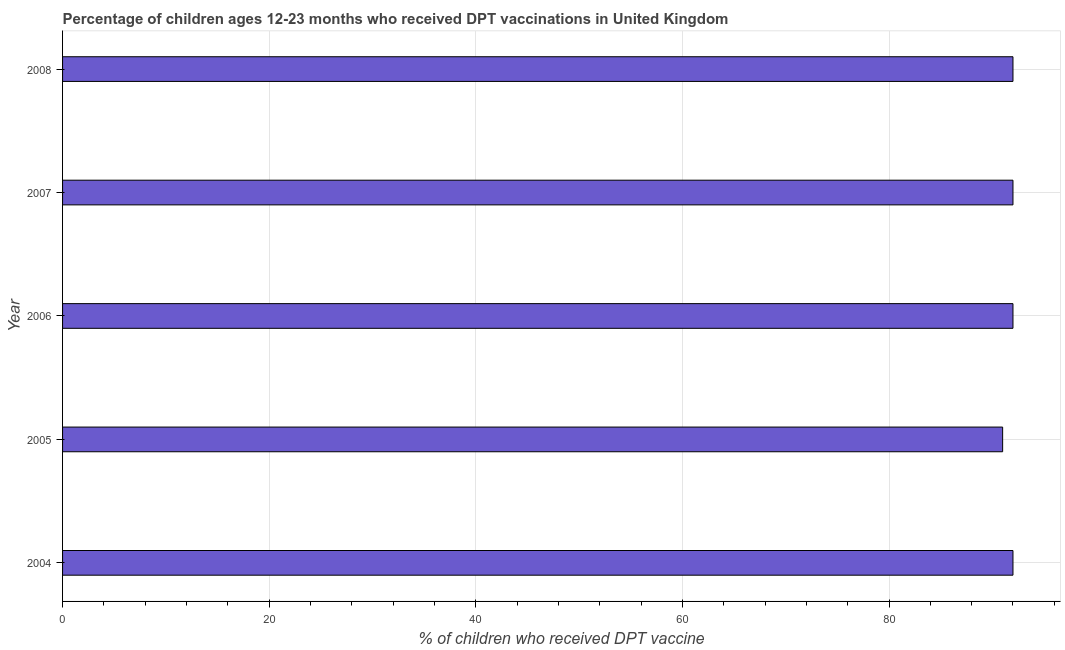Does the graph contain any zero values?
Offer a terse response. No. What is the title of the graph?
Ensure brevity in your answer.  Percentage of children ages 12-23 months who received DPT vaccinations in United Kingdom. What is the label or title of the X-axis?
Offer a terse response. % of children who received DPT vaccine. What is the percentage of children who received dpt vaccine in 2006?
Make the answer very short. 92. Across all years, what is the maximum percentage of children who received dpt vaccine?
Offer a terse response. 92. Across all years, what is the minimum percentage of children who received dpt vaccine?
Give a very brief answer. 91. What is the sum of the percentage of children who received dpt vaccine?
Keep it short and to the point. 459. What is the difference between the percentage of children who received dpt vaccine in 2007 and 2008?
Ensure brevity in your answer.  0. What is the average percentage of children who received dpt vaccine per year?
Give a very brief answer. 91. What is the median percentage of children who received dpt vaccine?
Ensure brevity in your answer.  92. Do a majority of the years between 2007 and 2004 (inclusive) have percentage of children who received dpt vaccine greater than 64 %?
Offer a terse response. Yes. Is the difference between the percentage of children who received dpt vaccine in 2006 and 2008 greater than the difference between any two years?
Provide a succinct answer. No. What is the difference between the highest and the second highest percentage of children who received dpt vaccine?
Offer a very short reply. 0. How many bars are there?
Give a very brief answer. 5. What is the % of children who received DPT vaccine of 2004?
Provide a succinct answer. 92. What is the % of children who received DPT vaccine of 2005?
Your response must be concise. 91. What is the % of children who received DPT vaccine in 2006?
Your answer should be compact. 92. What is the % of children who received DPT vaccine of 2007?
Ensure brevity in your answer.  92. What is the % of children who received DPT vaccine of 2008?
Offer a very short reply. 92. What is the difference between the % of children who received DPT vaccine in 2004 and 2007?
Offer a terse response. 0. What is the ratio of the % of children who received DPT vaccine in 2004 to that in 2005?
Your answer should be compact. 1.01. What is the ratio of the % of children who received DPT vaccine in 2004 to that in 2006?
Give a very brief answer. 1. What is the ratio of the % of children who received DPT vaccine in 2004 to that in 2007?
Your response must be concise. 1. What is the ratio of the % of children who received DPT vaccine in 2005 to that in 2007?
Offer a terse response. 0.99. What is the ratio of the % of children who received DPT vaccine in 2006 to that in 2008?
Ensure brevity in your answer.  1. What is the ratio of the % of children who received DPT vaccine in 2007 to that in 2008?
Keep it short and to the point. 1. 